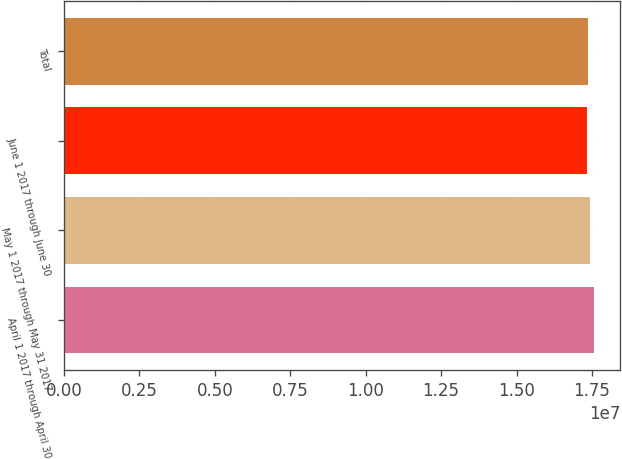Convert chart. <chart><loc_0><loc_0><loc_500><loc_500><bar_chart><fcel>April 1 2017 through April 30<fcel>May 1 2017 through May 31 2017<fcel>June 1 2017 through June 30<fcel>Total<nl><fcel>1.75592e+07<fcel>1.74492e+07<fcel>1.73403e+07<fcel>1.73622e+07<nl></chart> 